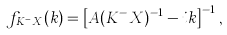Convert formula to latex. <formula><loc_0><loc_0><loc_500><loc_500>f _ { K ^ { - } X } ( k ) = \left [ A ( K ^ { - } X ) ^ { - 1 } - i k \right ] ^ { - 1 } ,</formula> 